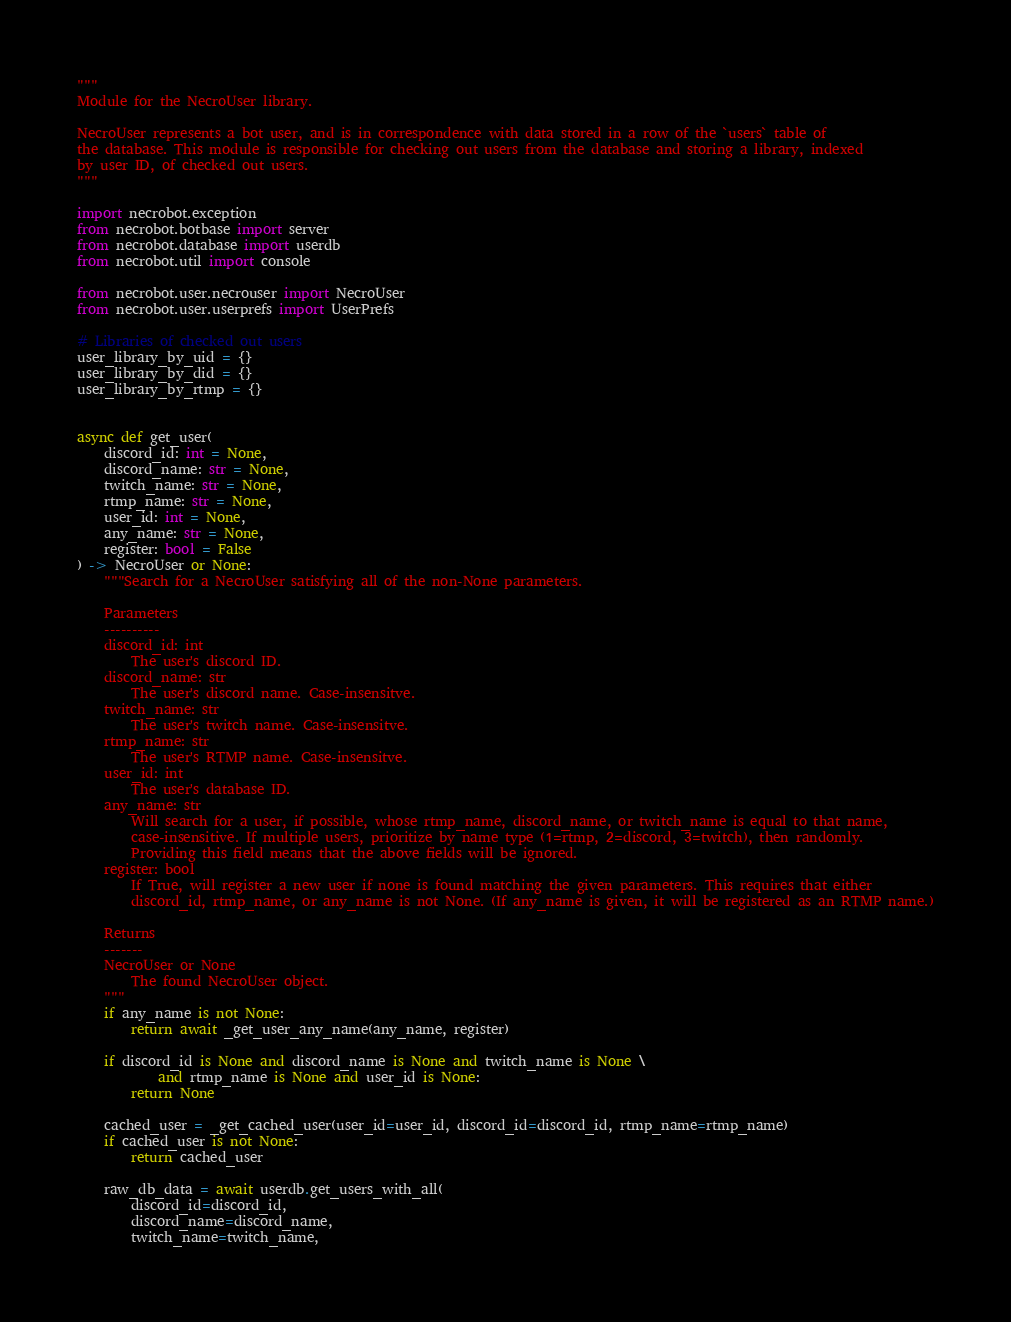<code> <loc_0><loc_0><loc_500><loc_500><_Python_>"""
Module for the NecroUser library.

NecroUser represents a bot user, and is in correspondence with data stored in a row of the `users` table of
the database. This module is responsible for checking out users from the database and storing a library, indexed
by user ID, of checked out users.
"""

import necrobot.exception
from necrobot.botbase import server
from necrobot.database import userdb
from necrobot.util import console

from necrobot.user.necrouser import NecroUser
from necrobot.user.userprefs import UserPrefs

# Libraries of checked out users
user_library_by_uid = {}
user_library_by_did = {}
user_library_by_rtmp = {}


async def get_user(
    discord_id: int = None,
    discord_name: str = None,
    twitch_name: str = None,
    rtmp_name: str = None,
    user_id: int = None,
    any_name: str = None,
    register: bool = False
) -> NecroUser or None:
    """Search for a NecroUser satisfying all of the non-None parameters.

    Parameters
    ----------
    discord_id: int
        The user's discord ID.
    discord_name: str
        The user's discord name. Case-insensitve.
    twitch_name: str
        The user's twitch name. Case-insensitve.
    rtmp_name: str
        The user's RTMP name. Case-insensitve.
    user_id: int
        The user's database ID.
    any_name: str
        Will search for a user, if possible, whose rtmp_name, discord_name, or twitch_name is equal to that name, 
        case-insensitive. If multiple users, prioritize by name type (1=rtmp, 2=discord, 3=twitch), then randomly.
        Providing this field means that the above fields will be ignored.
    register: bool
        If True, will register a new user if none is found matching the given parameters. This requires that either
        discord_id, rtmp_name, or any_name is not None. (If any_name is given, it will be registered as an RTMP name.)

    Returns
    -------
    NecroUser or None
        The found NecroUser object.
    """
    if any_name is not None:
        return await _get_user_any_name(any_name, register)

    if discord_id is None and discord_name is None and twitch_name is None \
            and rtmp_name is None and user_id is None:
        return None

    cached_user = _get_cached_user(user_id=user_id, discord_id=discord_id, rtmp_name=rtmp_name)
    if cached_user is not None:
        return cached_user

    raw_db_data = await userdb.get_users_with_all(
        discord_id=discord_id,
        discord_name=discord_name,
        twitch_name=twitch_name,</code> 